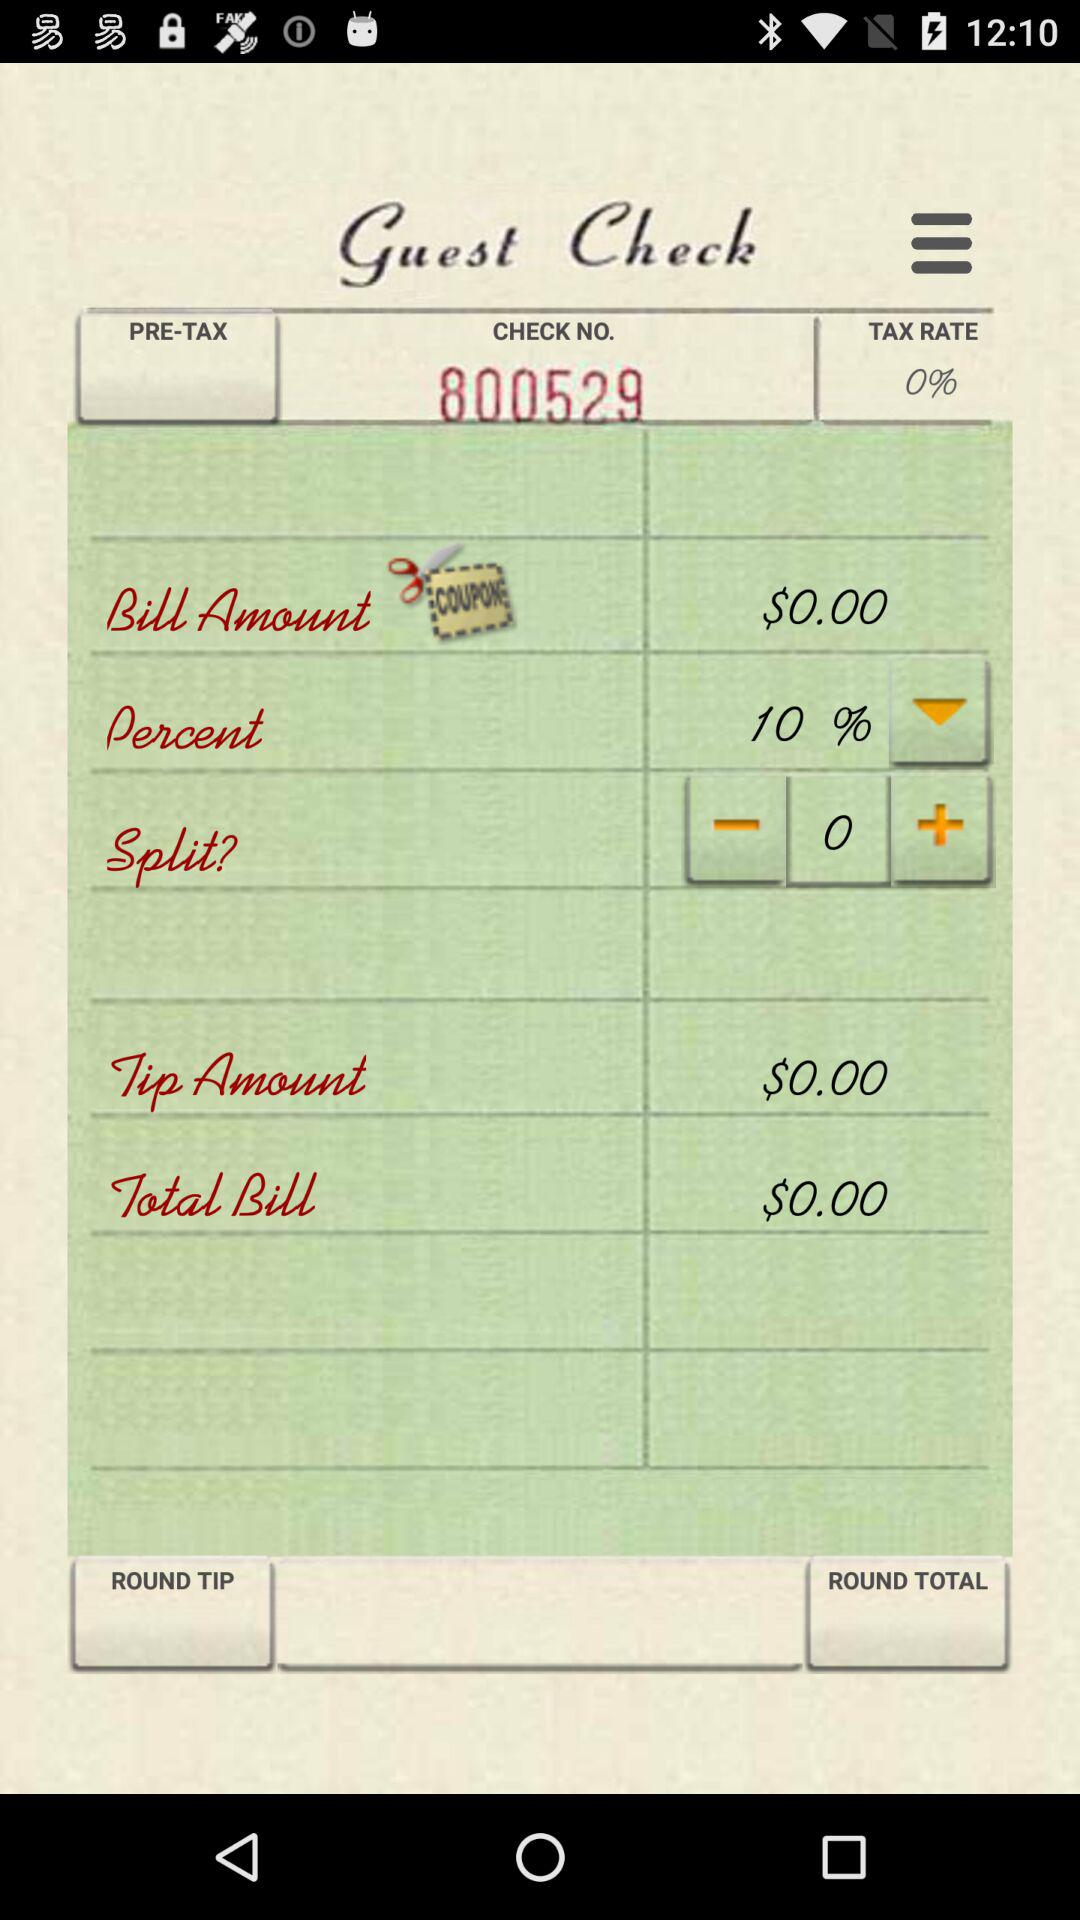What is the total amount of the bill before adding any taxes or tips?
Answer the question using a single word or phrase. $0.00 